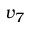<formula> <loc_0><loc_0><loc_500><loc_500>v _ { 7 }</formula> 